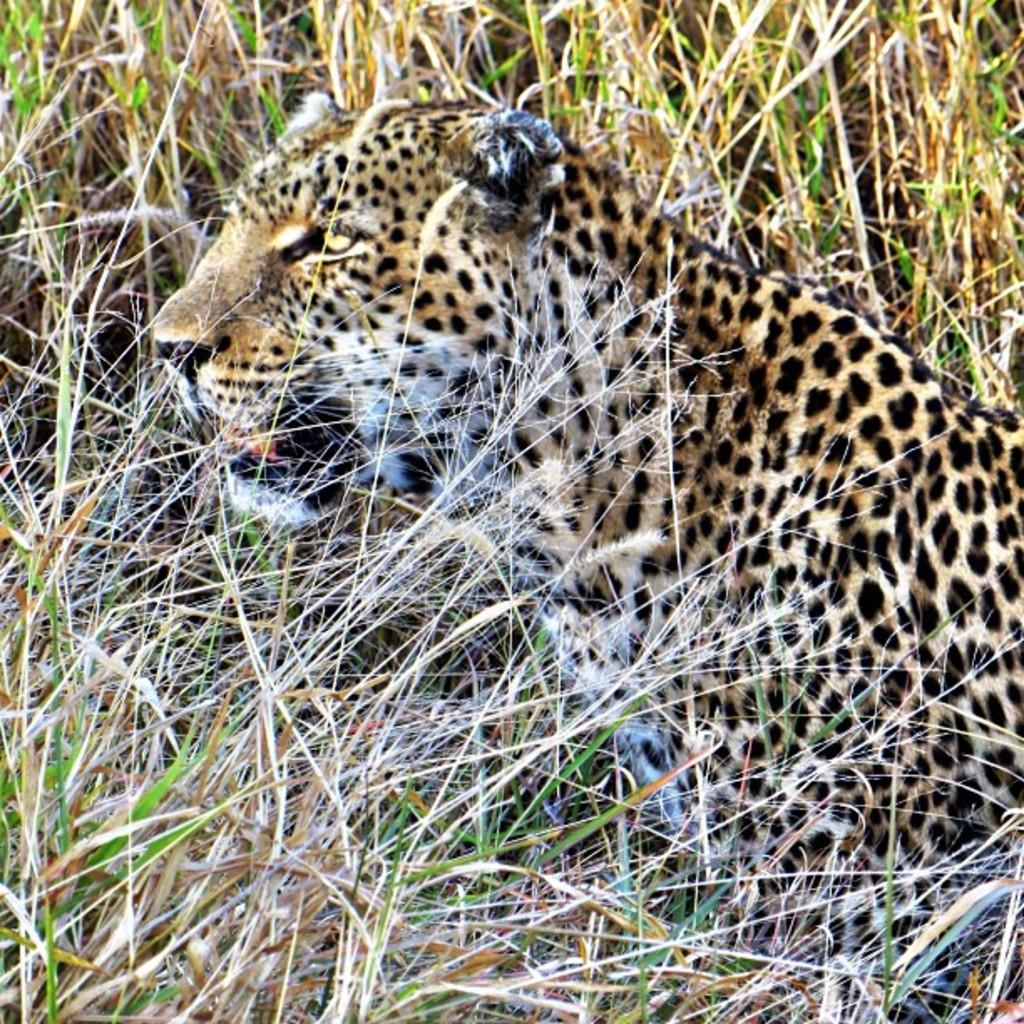What animal is present in the image? There is a leopard in the image. What is the leopard doing in the image? The leopard is sitting in the field. What type of sound can be heard coming from the crook in the image? There is no crook or sound mentioned in the image; it features a leopard sitting in a field. 